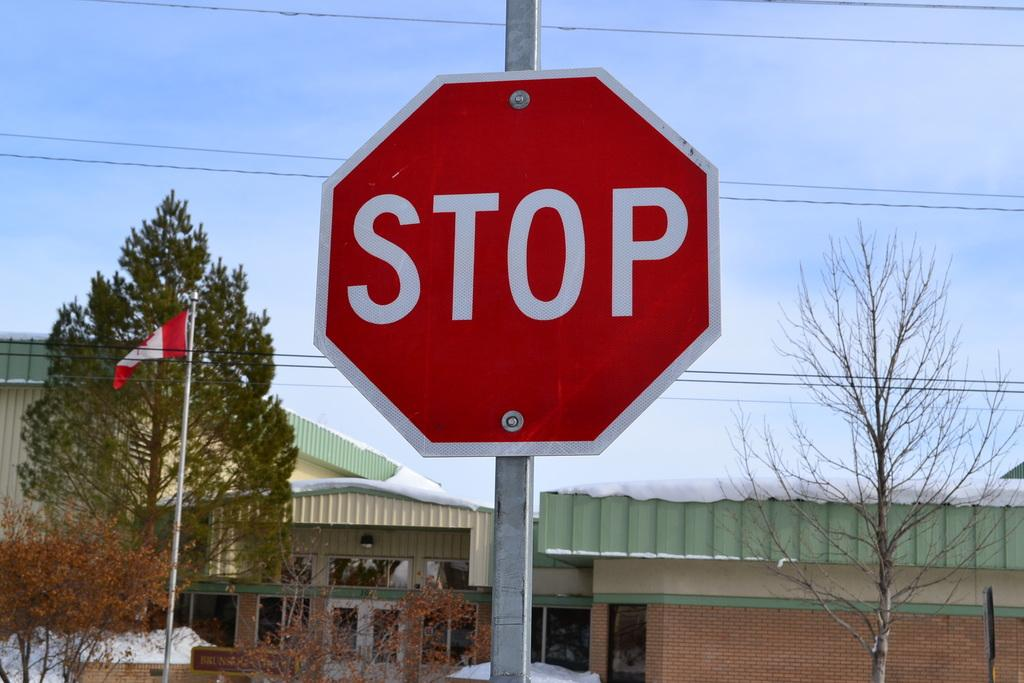<image>
Provide a brief description of the given image. Stop Sign and a Canadian flag that are shown next to a building. 